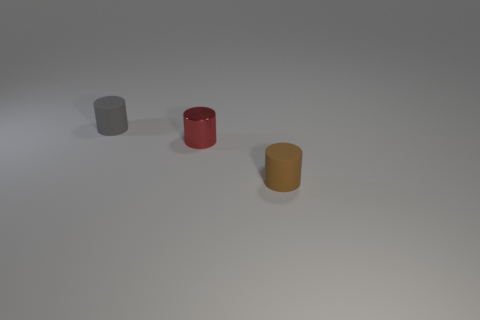There is a object that is on the right side of the tiny red thing; what number of tiny brown matte cylinders are on the right side of it?
Keep it short and to the point. 0. How many other objects are there of the same material as the gray object?
Provide a succinct answer. 1. What shape is the tiny matte object that is in front of the matte object that is to the left of the brown matte object?
Your answer should be very brief. Cylinder. There is a rubber cylinder behind the brown matte cylinder; how big is it?
Offer a terse response. Small. Do the tiny brown thing and the small gray thing have the same material?
Make the answer very short. Yes. There is a brown thing that is the same material as the gray thing; what shape is it?
Your response must be concise. Cylinder. There is a matte object in front of the metallic cylinder; what is its color?
Offer a terse response. Brown. There is a red thing that is the same shape as the brown object; what is its material?
Your answer should be very brief. Metal. How many cylinders are the same size as the red object?
Provide a succinct answer. 2. What is the size of the cylinder that is right of the gray rubber object and to the left of the brown object?
Offer a very short reply. Small. 